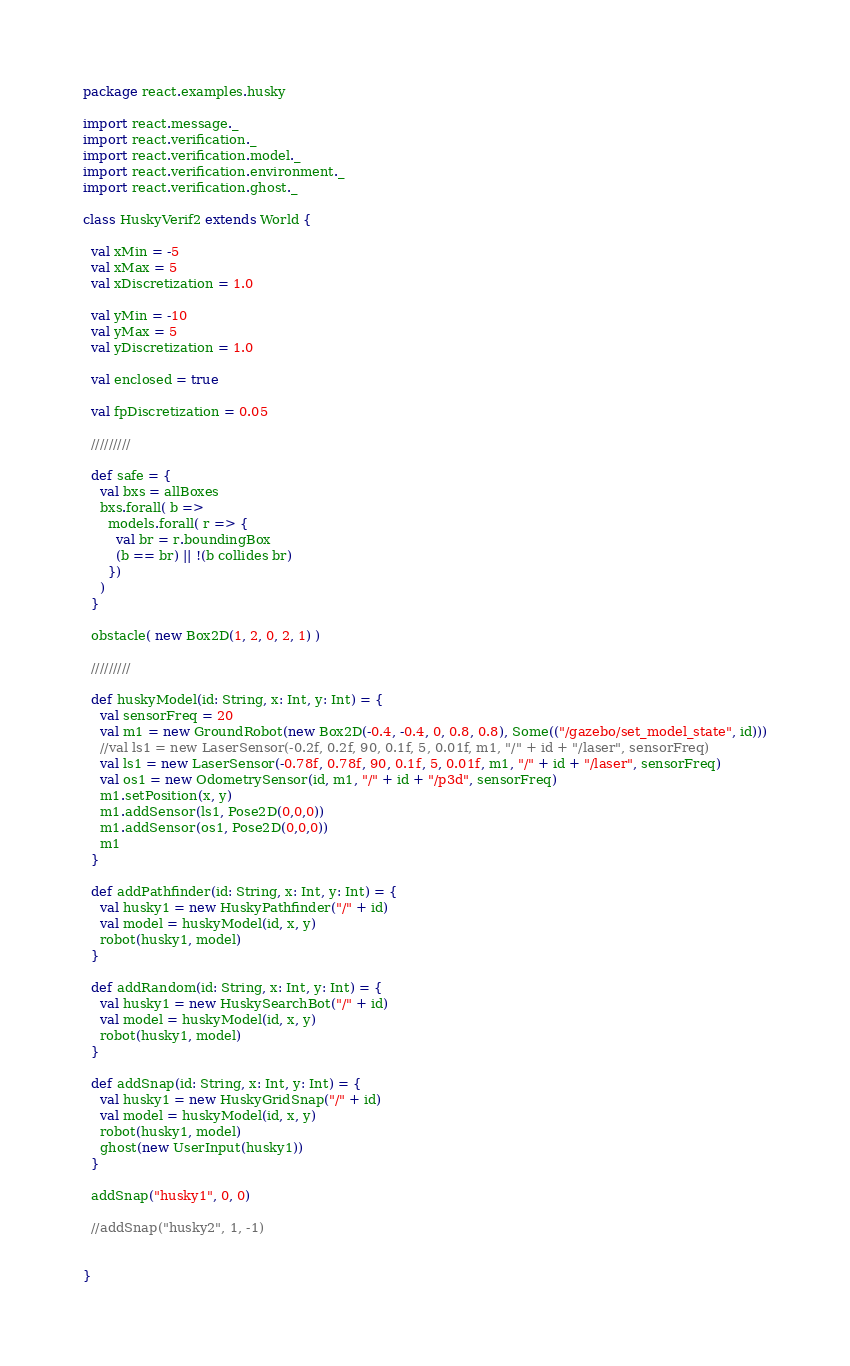Convert code to text. <code><loc_0><loc_0><loc_500><loc_500><_Scala_>package react.examples.husky

import react.message._
import react.verification._
import react.verification.model._
import react.verification.environment._
import react.verification.ghost._

class HuskyVerif2 extends World {

  val xMin = -5
  val xMax = 5
  val xDiscretization = 1.0

  val yMin = -10
  val yMax = 5
  val yDiscretization = 1.0

  val enclosed = true

  val fpDiscretization = 0.05
  
  /////////

  def safe = {
    val bxs = allBoxes
    bxs.forall( b =>
      models.forall( r => {
        val br = r.boundingBox
        (b == br) || !(b collides br)
      })
    )
  }

  obstacle( new Box2D(1, 2, 0, 2, 1) )

  /////////

  def huskyModel(id: String, x: Int, y: Int) = {
    val sensorFreq = 20
    val m1 = new GroundRobot(new Box2D(-0.4, -0.4, 0, 0.8, 0.8), Some(("/gazebo/set_model_state", id)))
    //val ls1 = new LaserSensor(-0.2f, 0.2f, 90, 0.1f, 5, 0.01f, m1, "/" + id + "/laser", sensorFreq)
    val ls1 = new LaserSensor(-0.78f, 0.78f, 90, 0.1f, 5, 0.01f, m1, "/" + id + "/laser", sensorFreq)
    val os1 = new OdometrySensor(id, m1, "/" + id + "/p3d", sensorFreq)
    m1.setPosition(x, y)
    m1.addSensor(ls1, Pose2D(0,0,0))
    m1.addSensor(os1, Pose2D(0,0,0))
    m1
  }

  def addPathfinder(id: String, x: Int, y: Int) = {
    val husky1 = new HuskyPathfinder("/" + id)
    val model = huskyModel(id, x, y)
    robot(husky1, model)
  }

  def addRandom(id: String, x: Int, y: Int) = {
    val husky1 = new HuskySearchBot("/" + id)
    val model = huskyModel(id, x, y)
    robot(husky1, model)
  }
  
  def addSnap(id: String, x: Int, y: Int) = {
    val husky1 = new HuskyGridSnap("/" + id)
    val model = huskyModel(id, x, y)
    robot(husky1, model)
    ghost(new UserInput(husky1))
  }

  addSnap("husky1", 0, 0)
  
  //addSnap("husky2", 1, -1)


}

</code> 